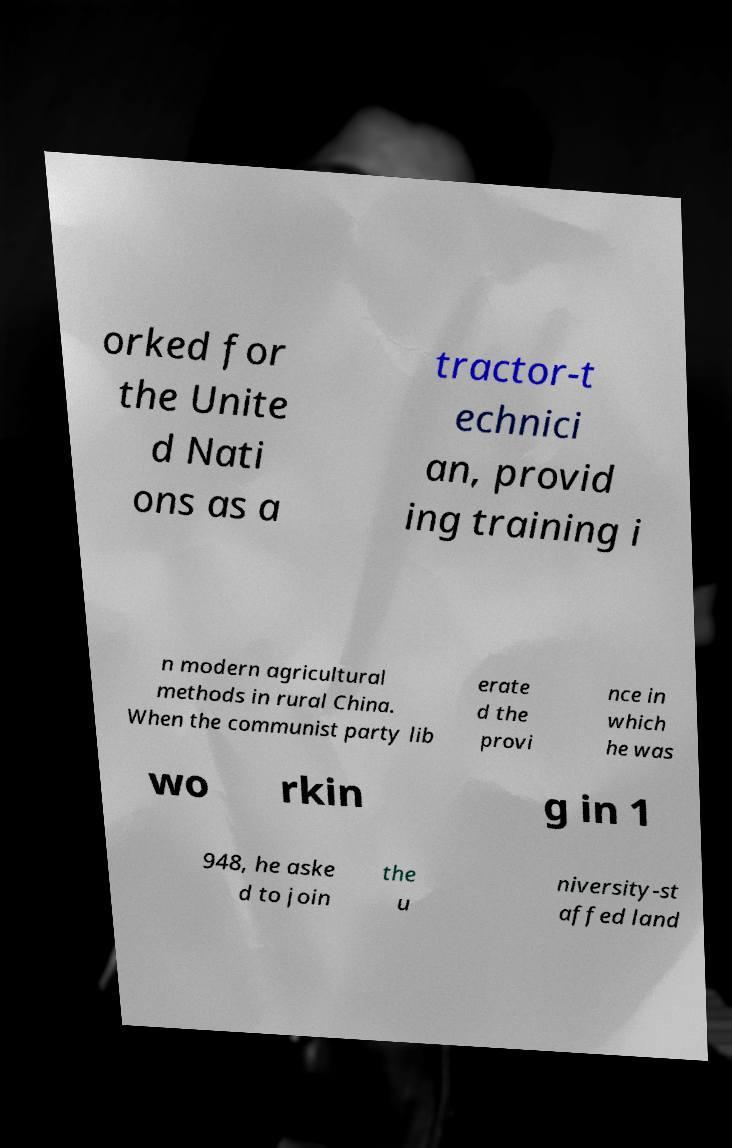Please read and relay the text visible in this image. What does it say? orked for the Unite d Nati ons as a tractor-t echnici an, provid ing training i n modern agricultural methods in rural China. When the communist party lib erate d the provi nce in which he was wo rkin g in 1 948, he aske d to join the u niversity-st affed land 